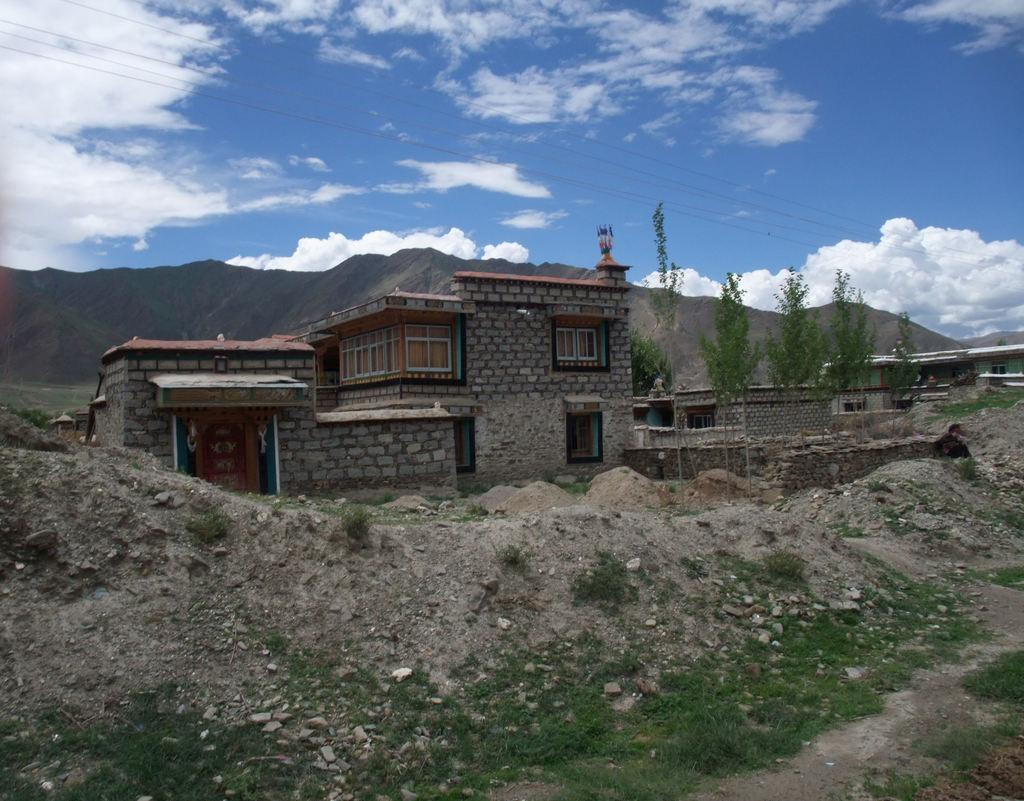What type of terrain is visible in the image? There is sand in the image. What structures can be seen in the image? There are buildings in the image. What type of vegetation is present in the image? There are trees in the image. What can be seen in the distance in the image? There are mountains in the background of the image. What is visible above the landscape in the image? The sky is visible in the background of the image. What type of stew is being prepared in the image? There is no stew present in the image; it features sand, buildings, trees, mountains, and the sky. What adjustments are being made to the trees in the image? There are no adjustments being made to the trees in the image; they are stationary. 